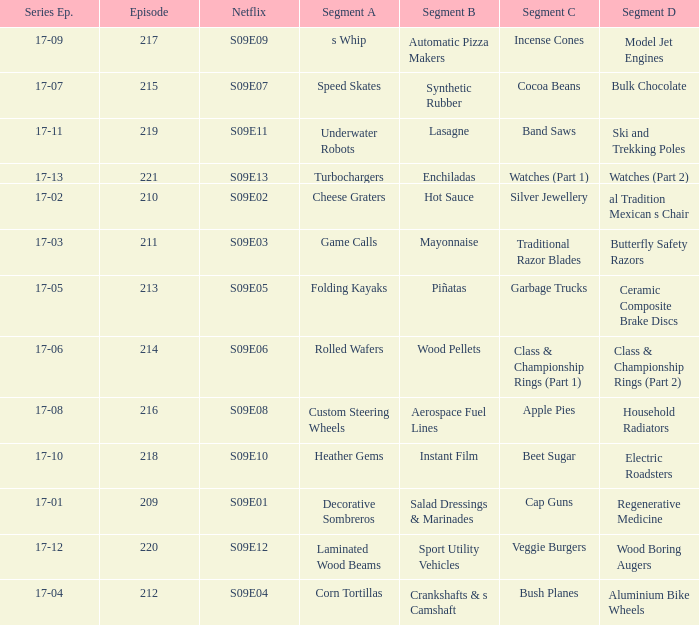Episode smaller than 210 had what segment c? Cap Guns. 